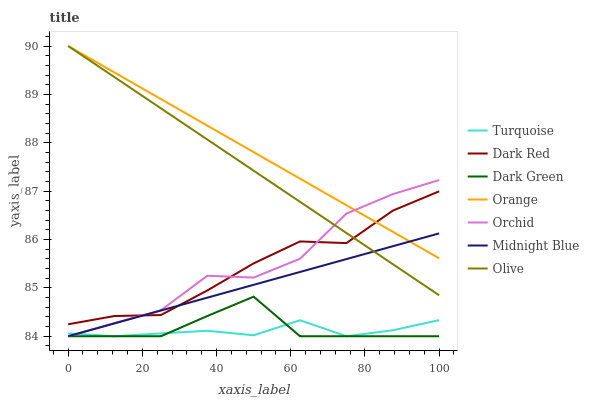Does Turquoise have the minimum area under the curve?
Answer yes or no. Yes. Does Orange have the maximum area under the curve?
Answer yes or no. Yes. Does Midnight Blue have the minimum area under the curve?
Answer yes or no. No. Does Midnight Blue have the maximum area under the curve?
Answer yes or no. No. Is Midnight Blue the smoothest?
Answer yes or no. Yes. Is Orchid the roughest?
Answer yes or no. Yes. Is Dark Red the smoothest?
Answer yes or no. No. Is Dark Red the roughest?
Answer yes or no. No. Does Turquoise have the lowest value?
Answer yes or no. Yes. Does Dark Red have the lowest value?
Answer yes or no. No. Does Orange have the highest value?
Answer yes or no. Yes. Does Midnight Blue have the highest value?
Answer yes or no. No. Is Dark Green less than Olive?
Answer yes or no. Yes. Is Orange greater than Dark Green?
Answer yes or no. Yes. Does Orange intersect Orchid?
Answer yes or no. Yes. Is Orange less than Orchid?
Answer yes or no. No. Is Orange greater than Orchid?
Answer yes or no. No. Does Dark Green intersect Olive?
Answer yes or no. No. 